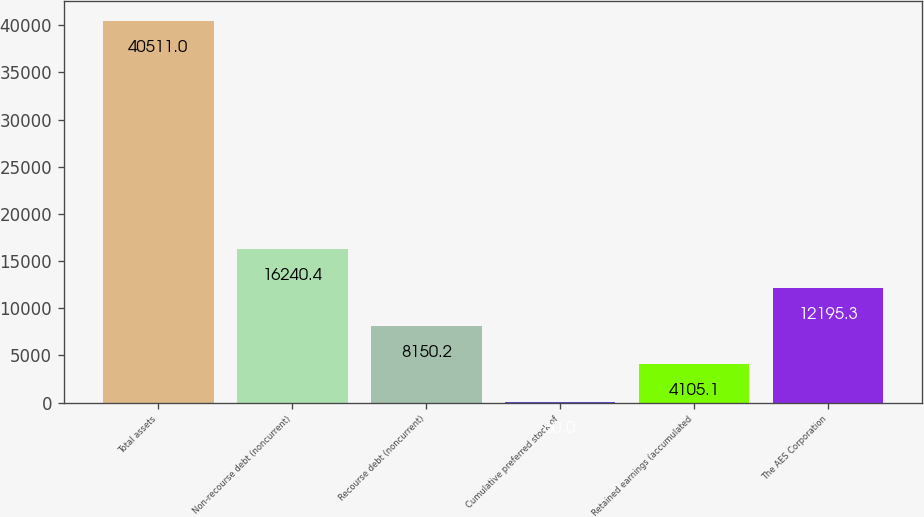<chart> <loc_0><loc_0><loc_500><loc_500><bar_chart><fcel>Total assets<fcel>Non-recourse debt (noncurrent)<fcel>Recourse debt (noncurrent)<fcel>Cumulative preferred stock of<fcel>Retained earnings (accumulated<fcel>The AES Corporation<nl><fcel>40511<fcel>16240.4<fcel>8150.2<fcel>60<fcel>4105.1<fcel>12195.3<nl></chart> 